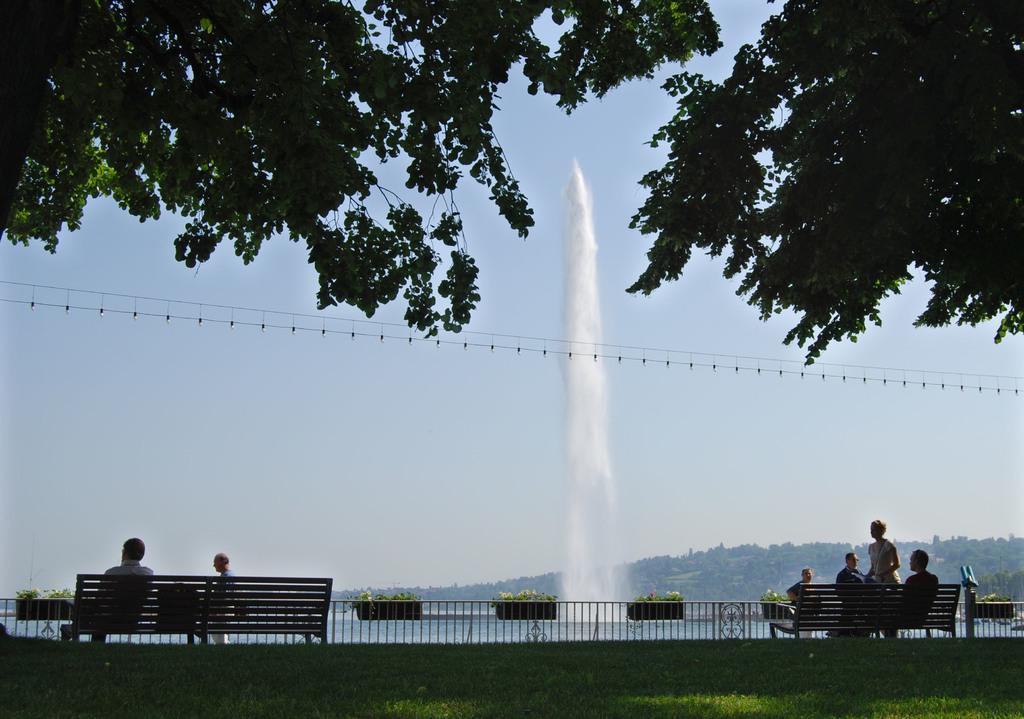How would you summarize this image in a sentence or two? In this image there are two benches, on the benches there are some persons sitting and some of them are walking and there is a railing. At the bottom there is grass and in the background there is a lake, mountains, trees and in the center there is some water coming up and there are lights. At the top of the image there are trees, and in the background there is sky. 